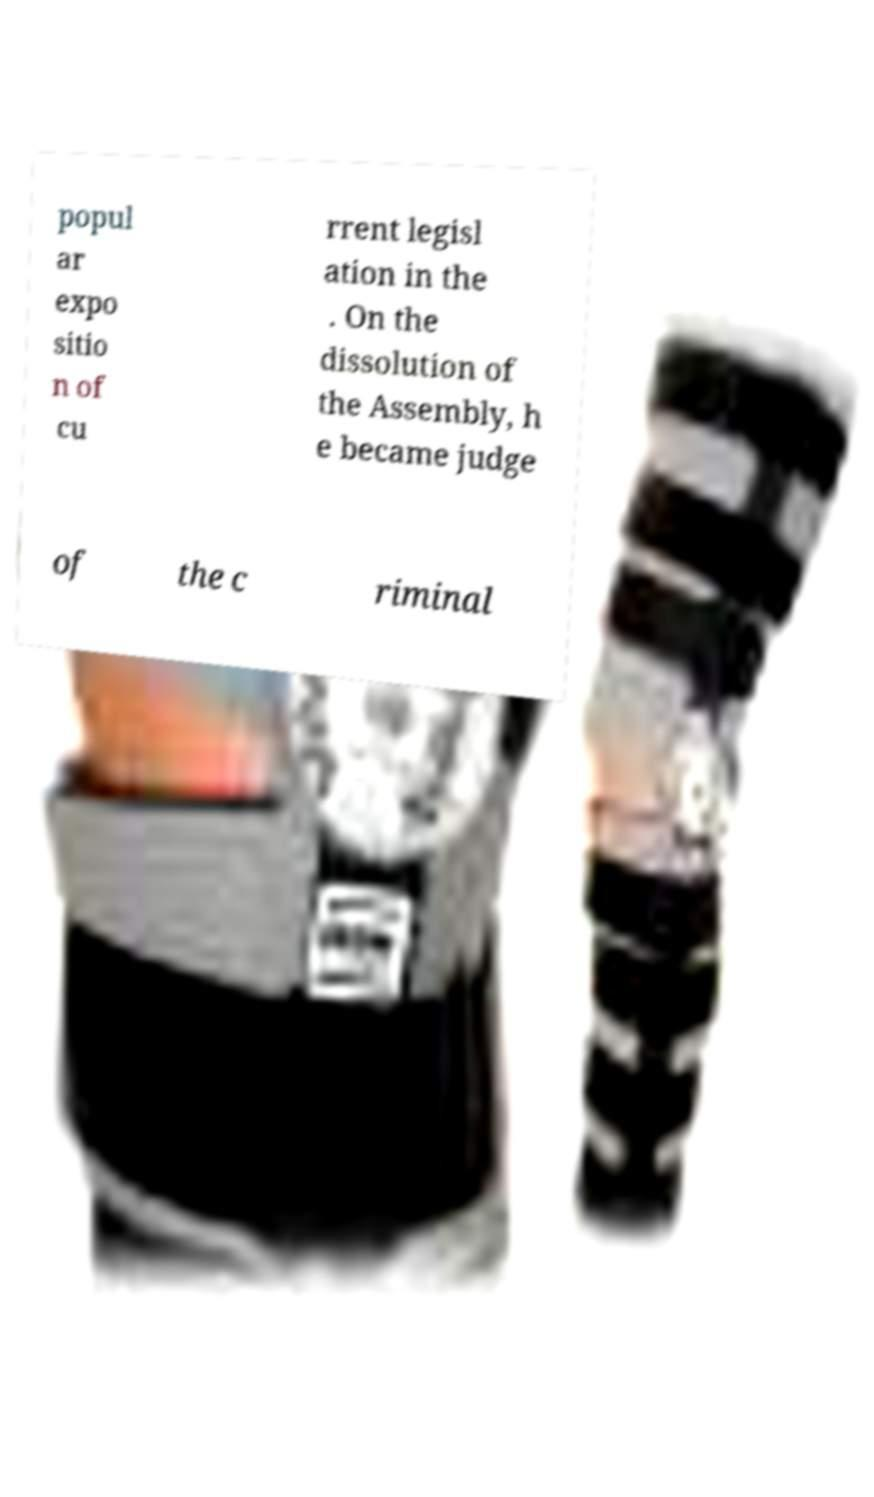Please identify and transcribe the text found in this image. popul ar expo sitio n of cu rrent legisl ation in the . On the dissolution of the Assembly, h e became judge of the c riminal 